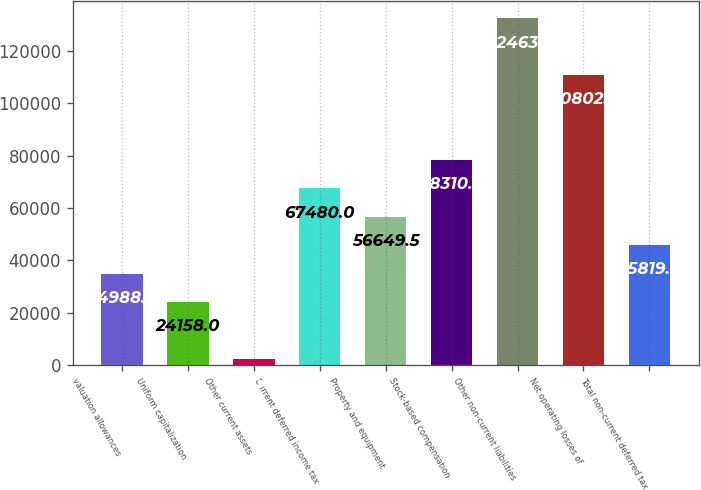<chart> <loc_0><loc_0><loc_500><loc_500><bar_chart><fcel>valuation allowances<fcel>Uniform capitalization<fcel>Other current assets<fcel>Current deferred income tax<fcel>Property and equipment<fcel>Stock-based compensation<fcel>Other non-current liabilities<fcel>Net operating losses of<fcel>Total non-current deferred tax<nl><fcel>34988.5<fcel>24158<fcel>2497<fcel>67480<fcel>56649.5<fcel>78310.5<fcel>132463<fcel>110802<fcel>45819<nl></chart> 